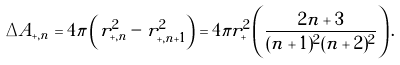<formula> <loc_0><loc_0><loc_500><loc_500>\Delta A _ { + , n } = 4 \pi \left ( r _ { + , n } ^ { 2 } - r _ { + , n + 1 } ^ { 2 } \right ) = 4 \pi r _ { + } ^ { 2 } \left ( \frac { 2 n + 3 } { ( n + 1 ) ^ { 2 } ( n + 2 ) ^ { 2 } } \right ) .</formula> 